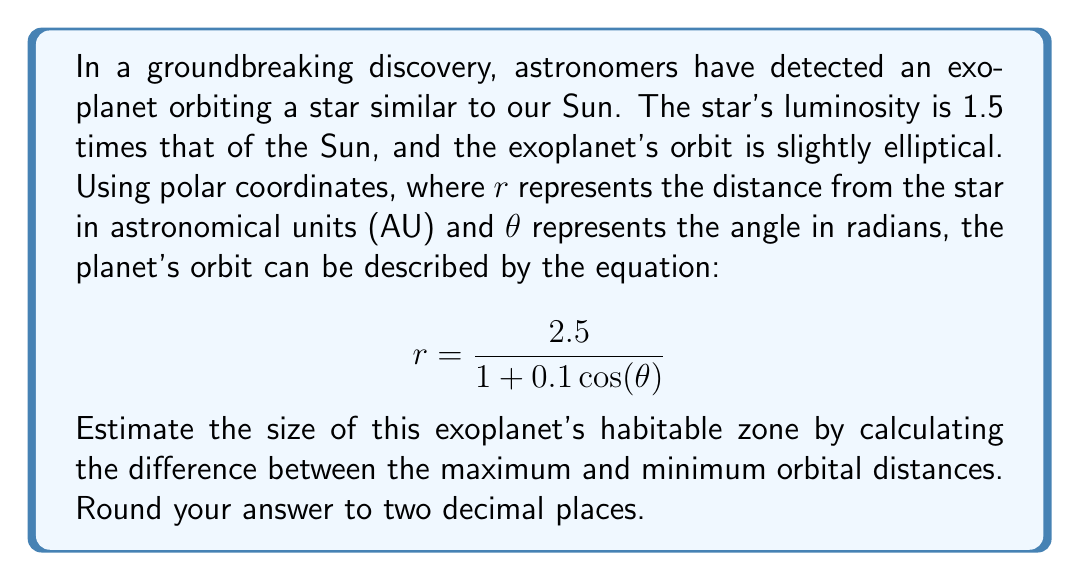Show me your answer to this math problem. To solve this problem, we need to follow these steps:

1) The habitable zone is typically defined as the range of distances from a star where liquid water could exist on a planet's surface. In this case, we can estimate it by finding the difference between the maximum and minimum distances of the planet's orbit.

2) In polar coordinates, the maximum distance occurs when $\cos(\theta) = -1$, and the minimum distance occurs when $\cos(\theta) = 1$.

3) For the maximum distance:
   $$r_{max} = \frac{2.5}{1 + 0.1(-1)} = \frac{2.5}{0.9} \approx 2.78 \text{ AU}$$

4) For the minimum distance:
   $$r_{min} = \frac{2.5}{1 + 0.1(1)} = \frac{2.5}{1.1} \approx 2.27 \text{ AU}$$

5) The size of the habitable zone can be estimated as the difference between these:
   $$\text{Size} = r_{max} - r_{min} \approx 2.78 - 2.27 = 0.51 \text{ AU}$$

6) Rounding to two decimal places gives 0.51 AU.

This result suggests a relatively wide habitable zone, which could increase the chances of the planet supporting liquid water and potentially life as we know it.
Answer: 0.51 AU 